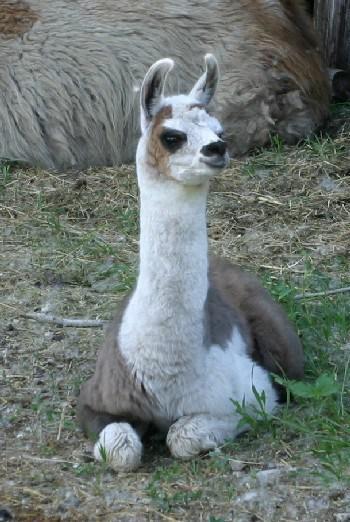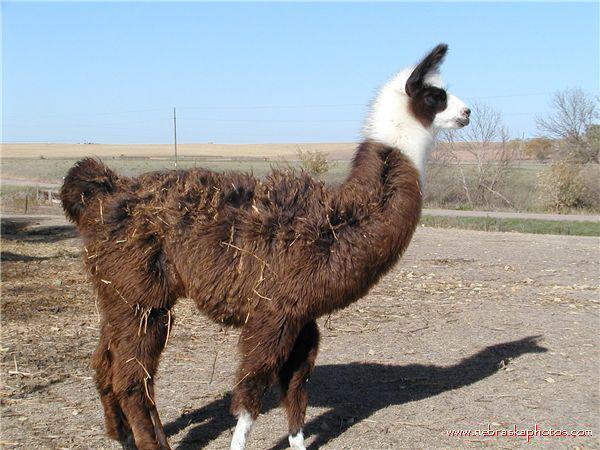The first image is the image on the left, the second image is the image on the right. Examine the images to the left and right. Is the description "One image shows two alpacas sitting next to each other." accurate? Answer yes or no. No. The first image is the image on the left, the second image is the image on the right. For the images displayed, is the sentence "One image includes a forward-facing standing llama, and the other image includes a reclining llama with another llama alongside it." factually correct? Answer yes or no. No. 